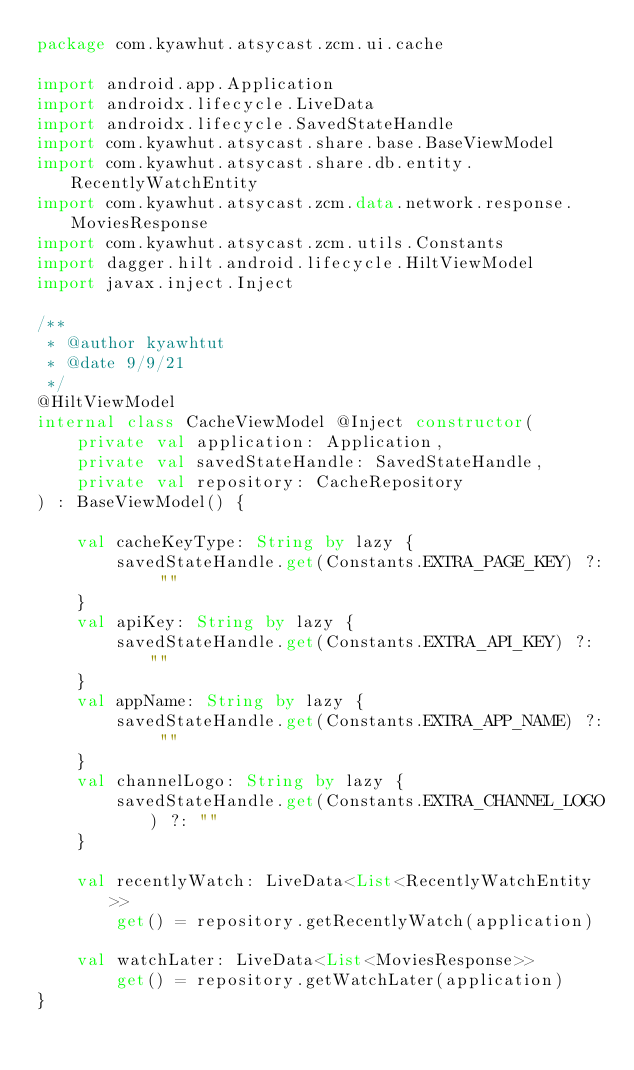<code> <loc_0><loc_0><loc_500><loc_500><_Kotlin_>package com.kyawhut.atsycast.zcm.ui.cache

import android.app.Application
import androidx.lifecycle.LiveData
import androidx.lifecycle.SavedStateHandle
import com.kyawhut.atsycast.share.base.BaseViewModel
import com.kyawhut.atsycast.share.db.entity.RecentlyWatchEntity
import com.kyawhut.atsycast.zcm.data.network.response.MoviesResponse
import com.kyawhut.atsycast.zcm.utils.Constants
import dagger.hilt.android.lifecycle.HiltViewModel
import javax.inject.Inject

/**
 * @author kyawhtut
 * @date 9/9/21
 */
@HiltViewModel
internal class CacheViewModel @Inject constructor(
    private val application: Application,
    private val savedStateHandle: SavedStateHandle,
    private val repository: CacheRepository
) : BaseViewModel() {

    val cacheKeyType: String by lazy {
        savedStateHandle.get(Constants.EXTRA_PAGE_KEY) ?: ""
    }
    val apiKey: String by lazy {
        savedStateHandle.get(Constants.EXTRA_API_KEY) ?: ""
    }
    val appName: String by lazy {
        savedStateHandle.get(Constants.EXTRA_APP_NAME) ?: ""
    }
    val channelLogo: String by lazy {
        savedStateHandle.get(Constants.EXTRA_CHANNEL_LOGO) ?: ""
    }

    val recentlyWatch: LiveData<List<RecentlyWatchEntity>>
        get() = repository.getRecentlyWatch(application)

    val watchLater: LiveData<List<MoviesResponse>>
        get() = repository.getWatchLater(application)
}
</code> 